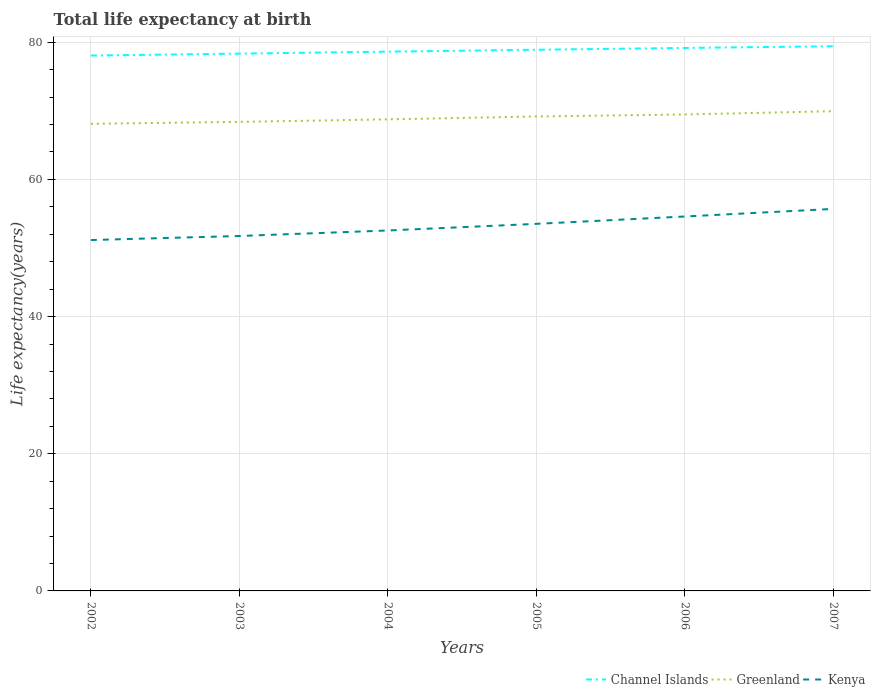How many different coloured lines are there?
Provide a short and direct response. 3. Is the number of lines equal to the number of legend labels?
Keep it short and to the point. Yes. Across all years, what is the maximum life expectancy at birth in in Kenya?
Offer a terse response. 51.16. What is the total life expectancy at birth in in Kenya in the graph?
Provide a short and direct response. -3.43. What is the difference between the highest and the second highest life expectancy at birth in in Channel Islands?
Offer a very short reply. 1.36. Is the life expectancy at birth in in Channel Islands strictly greater than the life expectancy at birth in in Greenland over the years?
Give a very brief answer. No. Are the values on the major ticks of Y-axis written in scientific E-notation?
Your response must be concise. No. Where does the legend appear in the graph?
Provide a succinct answer. Bottom right. How are the legend labels stacked?
Keep it short and to the point. Horizontal. What is the title of the graph?
Your answer should be very brief. Total life expectancy at birth. Does "Tonga" appear as one of the legend labels in the graph?
Make the answer very short. No. What is the label or title of the Y-axis?
Ensure brevity in your answer.  Life expectancy(years). What is the Life expectancy(years) in Channel Islands in 2002?
Ensure brevity in your answer.  78.06. What is the Life expectancy(years) of Greenland in 2002?
Keep it short and to the point. 68.11. What is the Life expectancy(years) in Kenya in 2002?
Offer a terse response. 51.16. What is the Life expectancy(years) in Channel Islands in 2003?
Provide a succinct answer. 78.34. What is the Life expectancy(years) in Greenland in 2003?
Your answer should be very brief. 68.38. What is the Life expectancy(years) in Kenya in 2003?
Ensure brevity in your answer.  51.75. What is the Life expectancy(years) in Channel Islands in 2004?
Give a very brief answer. 78.63. What is the Life expectancy(years) in Greenland in 2004?
Offer a terse response. 68.76. What is the Life expectancy(years) of Kenya in 2004?
Make the answer very short. 52.55. What is the Life expectancy(years) of Channel Islands in 2005?
Your answer should be compact. 78.9. What is the Life expectancy(years) in Greenland in 2005?
Keep it short and to the point. 69.18. What is the Life expectancy(years) of Kenya in 2005?
Your answer should be compact. 53.52. What is the Life expectancy(years) in Channel Islands in 2006?
Offer a terse response. 79.17. What is the Life expectancy(years) of Greenland in 2006?
Provide a succinct answer. 69.47. What is the Life expectancy(years) of Kenya in 2006?
Your answer should be compact. 54.59. What is the Life expectancy(years) of Channel Islands in 2007?
Make the answer very short. 79.41. What is the Life expectancy(years) in Greenland in 2007?
Provide a short and direct response. 69.94. What is the Life expectancy(years) in Kenya in 2007?
Your answer should be compact. 55.7. Across all years, what is the maximum Life expectancy(years) of Channel Islands?
Provide a short and direct response. 79.41. Across all years, what is the maximum Life expectancy(years) of Greenland?
Offer a very short reply. 69.94. Across all years, what is the maximum Life expectancy(years) in Kenya?
Your response must be concise. 55.7. Across all years, what is the minimum Life expectancy(years) of Channel Islands?
Your response must be concise. 78.06. Across all years, what is the minimum Life expectancy(years) in Greenland?
Give a very brief answer. 68.11. Across all years, what is the minimum Life expectancy(years) of Kenya?
Provide a succinct answer. 51.16. What is the total Life expectancy(years) in Channel Islands in the graph?
Offer a terse response. 472.5. What is the total Life expectancy(years) in Greenland in the graph?
Your answer should be compact. 413.83. What is the total Life expectancy(years) in Kenya in the graph?
Make the answer very short. 319.27. What is the difference between the Life expectancy(years) of Channel Islands in 2002 and that in 2003?
Provide a succinct answer. -0.28. What is the difference between the Life expectancy(years) in Greenland in 2002 and that in 2003?
Your answer should be compact. -0.28. What is the difference between the Life expectancy(years) in Kenya in 2002 and that in 2003?
Give a very brief answer. -0.59. What is the difference between the Life expectancy(years) in Channel Islands in 2002 and that in 2004?
Provide a short and direct response. -0.57. What is the difference between the Life expectancy(years) of Greenland in 2002 and that in 2004?
Your answer should be very brief. -0.65. What is the difference between the Life expectancy(years) of Kenya in 2002 and that in 2004?
Provide a short and direct response. -1.39. What is the difference between the Life expectancy(years) of Channel Islands in 2002 and that in 2005?
Offer a very short reply. -0.85. What is the difference between the Life expectancy(years) of Greenland in 2002 and that in 2005?
Your answer should be very brief. -1.07. What is the difference between the Life expectancy(years) of Kenya in 2002 and that in 2005?
Keep it short and to the point. -2.36. What is the difference between the Life expectancy(years) in Channel Islands in 2002 and that in 2006?
Your answer should be compact. -1.11. What is the difference between the Life expectancy(years) in Greenland in 2002 and that in 2006?
Provide a succinct answer. -1.36. What is the difference between the Life expectancy(years) in Kenya in 2002 and that in 2006?
Keep it short and to the point. -3.43. What is the difference between the Life expectancy(years) in Channel Islands in 2002 and that in 2007?
Your answer should be very brief. -1.35. What is the difference between the Life expectancy(years) of Greenland in 2002 and that in 2007?
Keep it short and to the point. -1.84. What is the difference between the Life expectancy(years) in Kenya in 2002 and that in 2007?
Your answer should be compact. -4.54. What is the difference between the Life expectancy(years) in Channel Islands in 2003 and that in 2004?
Ensure brevity in your answer.  -0.29. What is the difference between the Life expectancy(years) of Greenland in 2003 and that in 2004?
Provide a short and direct response. -0.37. What is the difference between the Life expectancy(years) of Kenya in 2003 and that in 2004?
Your answer should be compact. -0.8. What is the difference between the Life expectancy(years) in Channel Islands in 2003 and that in 2005?
Provide a short and direct response. -0.56. What is the difference between the Life expectancy(years) in Greenland in 2003 and that in 2005?
Keep it short and to the point. -0.79. What is the difference between the Life expectancy(years) of Kenya in 2003 and that in 2005?
Provide a succinct answer. -1.77. What is the difference between the Life expectancy(years) of Channel Islands in 2003 and that in 2006?
Your answer should be very brief. -0.83. What is the difference between the Life expectancy(years) in Greenland in 2003 and that in 2006?
Your answer should be compact. -1.08. What is the difference between the Life expectancy(years) in Kenya in 2003 and that in 2006?
Ensure brevity in your answer.  -2.84. What is the difference between the Life expectancy(years) of Channel Islands in 2003 and that in 2007?
Offer a very short reply. -1.07. What is the difference between the Life expectancy(years) of Greenland in 2003 and that in 2007?
Keep it short and to the point. -1.56. What is the difference between the Life expectancy(years) of Kenya in 2003 and that in 2007?
Keep it short and to the point. -3.95. What is the difference between the Life expectancy(years) of Channel Islands in 2004 and that in 2005?
Keep it short and to the point. -0.28. What is the difference between the Life expectancy(years) in Greenland in 2004 and that in 2005?
Your answer should be compact. -0.42. What is the difference between the Life expectancy(years) in Kenya in 2004 and that in 2005?
Offer a very short reply. -0.97. What is the difference between the Life expectancy(years) in Channel Islands in 2004 and that in 2006?
Keep it short and to the point. -0.54. What is the difference between the Life expectancy(years) in Greenland in 2004 and that in 2006?
Your answer should be very brief. -0.71. What is the difference between the Life expectancy(years) in Kenya in 2004 and that in 2006?
Give a very brief answer. -2.04. What is the difference between the Life expectancy(years) of Channel Islands in 2004 and that in 2007?
Provide a succinct answer. -0.79. What is the difference between the Life expectancy(years) in Greenland in 2004 and that in 2007?
Your response must be concise. -1.19. What is the difference between the Life expectancy(years) of Kenya in 2004 and that in 2007?
Your answer should be very brief. -3.15. What is the difference between the Life expectancy(years) of Channel Islands in 2005 and that in 2006?
Give a very brief answer. -0.26. What is the difference between the Life expectancy(years) in Greenland in 2005 and that in 2006?
Make the answer very short. -0.29. What is the difference between the Life expectancy(years) in Kenya in 2005 and that in 2006?
Your answer should be very brief. -1.07. What is the difference between the Life expectancy(years) in Channel Islands in 2005 and that in 2007?
Give a very brief answer. -0.51. What is the difference between the Life expectancy(years) in Greenland in 2005 and that in 2007?
Your answer should be very brief. -0.77. What is the difference between the Life expectancy(years) in Kenya in 2005 and that in 2007?
Provide a succinct answer. -2.18. What is the difference between the Life expectancy(years) in Channel Islands in 2006 and that in 2007?
Your answer should be very brief. -0.24. What is the difference between the Life expectancy(years) of Greenland in 2006 and that in 2007?
Provide a succinct answer. -0.47. What is the difference between the Life expectancy(years) in Kenya in 2006 and that in 2007?
Offer a very short reply. -1.11. What is the difference between the Life expectancy(years) of Channel Islands in 2002 and the Life expectancy(years) of Greenland in 2003?
Give a very brief answer. 9.67. What is the difference between the Life expectancy(years) in Channel Islands in 2002 and the Life expectancy(years) in Kenya in 2003?
Provide a succinct answer. 26.31. What is the difference between the Life expectancy(years) of Greenland in 2002 and the Life expectancy(years) of Kenya in 2003?
Make the answer very short. 16.36. What is the difference between the Life expectancy(years) in Channel Islands in 2002 and the Life expectancy(years) in Greenland in 2004?
Make the answer very short. 9.3. What is the difference between the Life expectancy(years) of Channel Islands in 2002 and the Life expectancy(years) of Kenya in 2004?
Your answer should be compact. 25.5. What is the difference between the Life expectancy(years) of Greenland in 2002 and the Life expectancy(years) of Kenya in 2004?
Make the answer very short. 15.55. What is the difference between the Life expectancy(years) in Channel Islands in 2002 and the Life expectancy(years) in Greenland in 2005?
Keep it short and to the point. 8.88. What is the difference between the Life expectancy(years) of Channel Islands in 2002 and the Life expectancy(years) of Kenya in 2005?
Ensure brevity in your answer.  24.54. What is the difference between the Life expectancy(years) of Greenland in 2002 and the Life expectancy(years) of Kenya in 2005?
Keep it short and to the point. 14.59. What is the difference between the Life expectancy(years) in Channel Islands in 2002 and the Life expectancy(years) in Greenland in 2006?
Make the answer very short. 8.59. What is the difference between the Life expectancy(years) in Channel Islands in 2002 and the Life expectancy(years) in Kenya in 2006?
Provide a succinct answer. 23.46. What is the difference between the Life expectancy(years) of Greenland in 2002 and the Life expectancy(years) of Kenya in 2006?
Provide a short and direct response. 13.52. What is the difference between the Life expectancy(years) of Channel Islands in 2002 and the Life expectancy(years) of Greenland in 2007?
Offer a very short reply. 8.11. What is the difference between the Life expectancy(years) in Channel Islands in 2002 and the Life expectancy(years) in Kenya in 2007?
Your response must be concise. 22.36. What is the difference between the Life expectancy(years) in Greenland in 2002 and the Life expectancy(years) in Kenya in 2007?
Your answer should be very brief. 12.41. What is the difference between the Life expectancy(years) in Channel Islands in 2003 and the Life expectancy(years) in Greenland in 2004?
Provide a succinct answer. 9.58. What is the difference between the Life expectancy(years) in Channel Islands in 2003 and the Life expectancy(years) in Kenya in 2004?
Your response must be concise. 25.79. What is the difference between the Life expectancy(years) of Greenland in 2003 and the Life expectancy(years) of Kenya in 2004?
Make the answer very short. 15.83. What is the difference between the Life expectancy(years) of Channel Islands in 2003 and the Life expectancy(years) of Greenland in 2005?
Offer a very short reply. 9.16. What is the difference between the Life expectancy(years) of Channel Islands in 2003 and the Life expectancy(years) of Kenya in 2005?
Your response must be concise. 24.82. What is the difference between the Life expectancy(years) of Greenland in 2003 and the Life expectancy(years) of Kenya in 2005?
Keep it short and to the point. 14.87. What is the difference between the Life expectancy(years) of Channel Islands in 2003 and the Life expectancy(years) of Greenland in 2006?
Offer a terse response. 8.87. What is the difference between the Life expectancy(years) of Channel Islands in 2003 and the Life expectancy(years) of Kenya in 2006?
Ensure brevity in your answer.  23.75. What is the difference between the Life expectancy(years) in Greenland in 2003 and the Life expectancy(years) in Kenya in 2006?
Provide a short and direct response. 13.79. What is the difference between the Life expectancy(years) of Channel Islands in 2003 and the Life expectancy(years) of Greenland in 2007?
Provide a short and direct response. 8.4. What is the difference between the Life expectancy(years) of Channel Islands in 2003 and the Life expectancy(years) of Kenya in 2007?
Give a very brief answer. 22.64. What is the difference between the Life expectancy(years) of Greenland in 2003 and the Life expectancy(years) of Kenya in 2007?
Offer a terse response. 12.69. What is the difference between the Life expectancy(years) of Channel Islands in 2004 and the Life expectancy(years) of Greenland in 2005?
Ensure brevity in your answer.  9.45. What is the difference between the Life expectancy(years) in Channel Islands in 2004 and the Life expectancy(years) in Kenya in 2005?
Give a very brief answer. 25.11. What is the difference between the Life expectancy(years) of Greenland in 2004 and the Life expectancy(years) of Kenya in 2005?
Ensure brevity in your answer.  15.24. What is the difference between the Life expectancy(years) in Channel Islands in 2004 and the Life expectancy(years) in Greenland in 2006?
Offer a terse response. 9.16. What is the difference between the Life expectancy(years) of Channel Islands in 2004 and the Life expectancy(years) of Kenya in 2006?
Keep it short and to the point. 24.03. What is the difference between the Life expectancy(years) in Greenland in 2004 and the Life expectancy(years) in Kenya in 2006?
Offer a very short reply. 14.16. What is the difference between the Life expectancy(years) of Channel Islands in 2004 and the Life expectancy(years) of Greenland in 2007?
Give a very brief answer. 8.68. What is the difference between the Life expectancy(years) of Channel Islands in 2004 and the Life expectancy(years) of Kenya in 2007?
Provide a short and direct response. 22.93. What is the difference between the Life expectancy(years) of Greenland in 2004 and the Life expectancy(years) of Kenya in 2007?
Offer a very short reply. 13.06. What is the difference between the Life expectancy(years) in Channel Islands in 2005 and the Life expectancy(years) in Greenland in 2006?
Give a very brief answer. 9.43. What is the difference between the Life expectancy(years) in Channel Islands in 2005 and the Life expectancy(years) in Kenya in 2006?
Provide a succinct answer. 24.31. What is the difference between the Life expectancy(years) in Greenland in 2005 and the Life expectancy(years) in Kenya in 2006?
Offer a terse response. 14.58. What is the difference between the Life expectancy(years) in Channel Islands in 2005 and the Life expectancy(years) in Greenland in 2007?
Your answer should be very brief. 8.96. What is the difference between the Life expectancy(years) of Channel Islands in 2005 and the Life expectancy(years) of Kenya in 2007?
Make the answer very short. 23.2. What is the difference between the Life expectancy(years) of Greenland in 2005 and the Life expectancy(years) of Kenya in 2007?
Give a very brief answer. 13.48. What is the difference between the Life expectancy(years) in Channel Islands in 2006 and the Life expectancy(years) in Greenland in 2007?
Offer a very short reply. 9.22. What is the difference between the Life expectancy(years) in Channel Islands in 2006 and the Life expectancy(years) in Kenya in 2007?
Keep it short and to the point. 23.47. What is the difference between the Life expectancy(years) of Greenland in 2006 and the Life expectancy(years) of Kenya in 2007?
Give a very brief answer. 13.77. What is the average Life expectancy(years) of Channel Islands per year?
Your answer should be compact. 78.75. What is the average Life expectancy(years) of Greenland per year?
Your answer should be very brief. 68.97. What is the average Life expectancy(years) of Kenya per year?
Keep it short and to the point. 53.21. In the year 2002, what is the difference between the Life expectancy(years) in Channel Islands and Life expectancy(years) in Greenland?
Keep it short and to the point. 9.95. In the year 2002, what is the difference between the Life expectancy(years) in Channel Islands and Life expectancy(years) in Kenya?
Keep it short and to the point. 26.9. In the year 2002, what is the difference between the Life expectancy(years) in Greenland and Life expectancy(years) in Kenya?
Make the answer very short. 16.95. In the year 2003, what is the difference between the Life expectancy(years) in Channel Islands and Life expectancy(years) in Greenland?
Your response must be concise. 9.96. In the year 2003, what is the difference between the Life expectancy(years) in Channel Islands and Life expectancy(years) in Kenya?
Keep it short and to the point. 26.59. In the year 2003, what is the difference between the Life expectancy(years) of Greenland and Life expectancy(years) of Kenya?
Provide a succinct answer. 16.64. In the year 2004, what is the difference between the Life expectancy(years) in Channel Islands and Life expectancy(years) in Greenland?
Ensure brevity in your answer.  9.87. In the year 2004, what is the difference between the Life expectancy(years) of Channel Islands and Life expectancy(years) of Kenya?
Offer a very short reply. 26.07. In the year 2004, what is the difference between the Life expectancy(years) in Greenland and Life expectancy(years) in Kenya?
Your response must be concise. 16.2. In the year 2005, what is the difference between the Life expectancy(years) in Channel Islands and Life expectancy(years) in Greenland?
Give a very brief answer. 9.73. In the year 2005, what is the difference between the Life expectancy(years) of Channel Islands and Life expectancy(years) of Kenya?
Provide a succinct answer. 25.38. In the year 2005, what is the difference between the Life expectancy(years) in Greenland and Life expectancy(years) in Kenya?
Keep it short and to the point. 15.66. In the year 2006, what is the difference between the Life expectancy(years) in Channel Islands and Life expectancy(years) in Greenland?
Your answer should be compact. 9.7. In the year 2006, what is the difference between the Life expectancy(years) of Channel Islands and Life expectancy(years) of Kenya?
Give a very brief answer. 24.58. In the year 2006, what is the difference between the Life expectancy(years) of Greenland and Life expectancy(years) of Kenya?
Your answer should be compact. 14.88. In the year 2007, what is the difference between the Life expectancy(years) of Channel Islands and Life expectancy(years) of Greenland?
Your answer should be very brief. 9.47. In the year 2007, what is the difference between the Life expectancy(years) in Channel Islands and Life expectancy(years) in Kenya?
Your response must be concise. 23.71. In the year 2007, what is the difference between the Life expectancy(years) of Greenland and Life expectancy(years) of Kenya?
Ensure brevity in your answer.  14.24. What is the ratio of the Life expectancy(years) in Greenland in 2002 to that in 2003?
Give a very brief answer. 1. What is the ratio of the Life expectancy(years) of Channel Islands in 2002 to that in 2004?
Make the answer very short. 0.99. What is the ratio of the Life expectancy(years) of Greenland in 2002 to that in 2004?
Give a very brief answer. 0.99. What is the ratio of the Life expectancy(years) in Kenya in 2002 to that in 2004?
Offer a very short reply. 0.97. What is the ratio of the Life expectancy(years) in Channel Islands in 2002 to that in 2005?
Give a very brief answer. 0.99. What is the ratio of the Life expectancy(years) in Greenland in 2002 to that in 2005?
Your answer should be compact. 0.98. What is the ratio of the Life expectancy(years) in Kenya in 2002 to that in 2005?
Ensure brevity in your answer.  0.96. What is the ratio of the Life expectancy(years) of Channel Islands in 2002 to that in 2006?
Your answer should be compact. 0.99. What is the ratio of the Life expectancy(years) of Greenland in 2002 to that in 2006?
Your answer should be compact. 0.98. What is the ratio of the Life expectancy(years) in Kenya in 2002 to that in 2006?
Your response must be concise. 0.94. What is the ratio of the Life expectancy(years) of Channel Islands in 2002 to that in 2007?
Keep it short and to the point. 0.98. What is the ratio of the Life expectancy(years) in Greenland in 2002 to that in 2007?
Give a very brief answer. 0.97. What is the ratio of the Life expectancy(years) of Kenya in 2002 to that in 2007?
Provide a succinct answer. 0.92. What is the ratio of the Life expectancy(years) in Kenya in 2003 to that in 2004?
Offer a terse response. 0.98. What is the ratio of the Life expectancy(years) of Greenland in 2003 to that in 2005?
Ensure brevity in your answer.  0.99. What is the ratio of the Life expectancy(years) in Kenya in 2003 to that in 2005?
Provide a short and direct response. 0.97. What is the ratio of the Life expectancy(years) of Channel Islands in 2003 to that in 2006?
Your response must be concise. 0.99. What is the ratio of the Life expectancy(years) in Greenland in 2003 to that in 2006?
Give a very brief answer. 0.98. What is the ratio of the Life expectancy(years) of Kenya in 2003 to that in 2006?
Provide a succinct answer. 0.95. What is the ratio of the Life expectancy(years) in Channel Islands in 2003 to that in 2007?
Provide a succinct answer. 0.99. What is the ratio of the Life expectancy(years) in Greenland in 2003 to that in 2007?
Keep it short and to the point. 0.98. What is the ratio of the Life expectancy(years) of Kenya in 2003 to that in 2007?
Give a very brief answer. 0.93. What is the ratio of the Life expectancy(years) of Kenya in 2004 to that in 2005?
Your answer should be compact. 0.98. What is the ratio of the Life expectancy(years) of Kenya in 2004 to that in 2006?
Make the answer very short. 0.96. What is the ratio of the Life expectancy(years) in Greenland in 2004 to that in 2007?
Your answer should be compact. 0.98. What is the ratio of the Life expectancy(years) in Kenya in 2004 to that in 2007?
Offer a very short reply. 0.94. What is the ratio of the Life expectancy(years) of Channel Islands in 2005 to that in 2006?
Keep it short and to the point. 1. What is the ratio of the Life expectancy(years) of Greenland in 2005 to that in 2006?
Ensure brevity in your answer.  1. What is the ratio of the Life expectancy(years) in Kenya in 2005 to that in 2006?
Ensure brevity in your answer.  0.98. What is the ratio of the Life expectancy(years) in Kenya in 2005 to that in 2007?
Give a very brief answer. 0.96. What is the ratio of the Life expectancy(years) in Channel Islands in 2006 to that in 2007?
Your answer should be very brief. 1. What is the ratio of the Life expectancy(years) in Kenya in 2006 to that in 2007?
Make the answer very short. 0.98. What is the difference between the highest and the second highest Life expectancy(years) of Channel Islands?
Ensure brevity in your answer.  0.24. What is the difference between the highest and the second highest Life expectancy(years) of Greenland?
Keep it short and to the point. 0.47. What is the difference between the highest and the second highest Life expectancy(years) in Kenya?
Your response must be concise. 1.11. What is the difference between the highest and the lowest Life expectancy(years) of Channel Islands?
Your answer should be very brief. 1.35. What is the difference between the highest and the lowest Life expectancy(years) of Greenland?
Provide a succinct answer. 1.84. What is the difference between the highest and the lowest Life expectancy(years) in Kenya?
Provide a succinct answer. 4.54. 